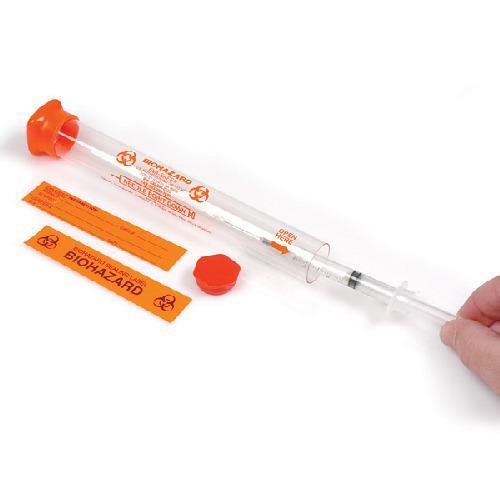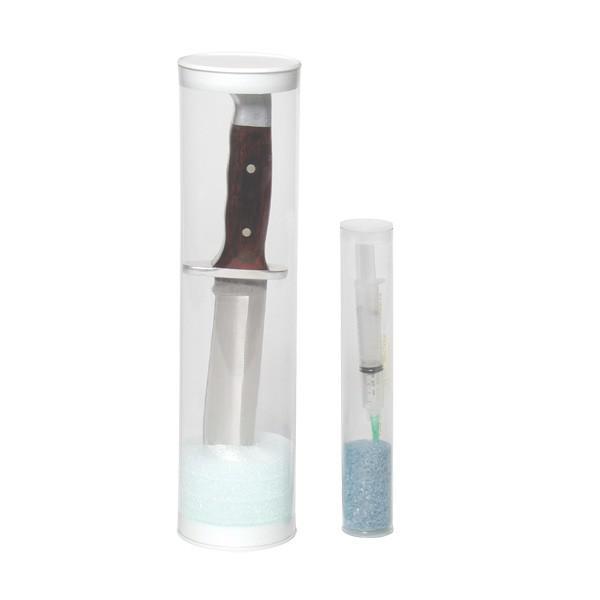The first image is the image on the left, the second image is the image on the right. Evaluate the accuracy of this statement regarding the images: "There are two canisters in the right image.". Is it true? Answer yes or no. Yes. The first image is the image on the left, the second image is the image on the right. Assess this claim about the two images: "An image shows at least three tubes with caps on the ends.". Correct or not? Answer yes or no. No. 